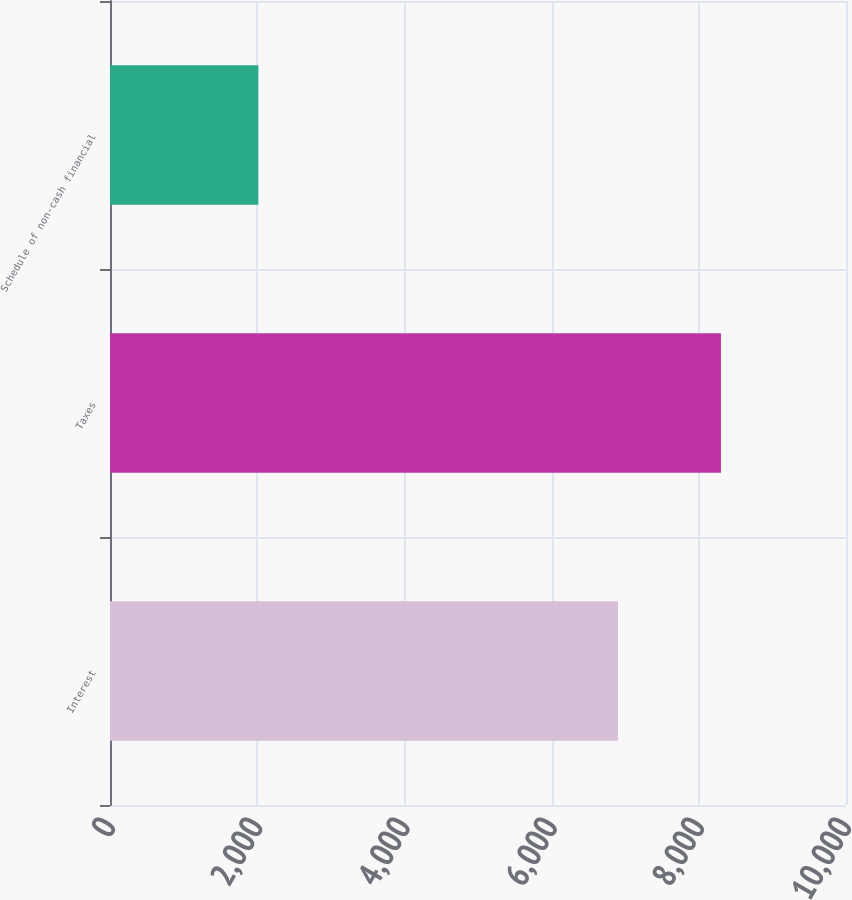Convert chart to OTSL. <chart><loc_0><loc_0><loc_500><loc_500><bar_chart><fcel>Interest<fcel>Taxes<fcel>Schedule of non-cash financial<nl><fcel>6902<fcel>8301<fcel>2016<nl></chart> 